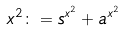Convert formula to latex. <formula><loc_0><loc_0><loc_500><loc_500>x ^ { 2 } \colon = s ^ { x ^ { 2 } } + a ^ { x ^ { 2 } }</formula> 